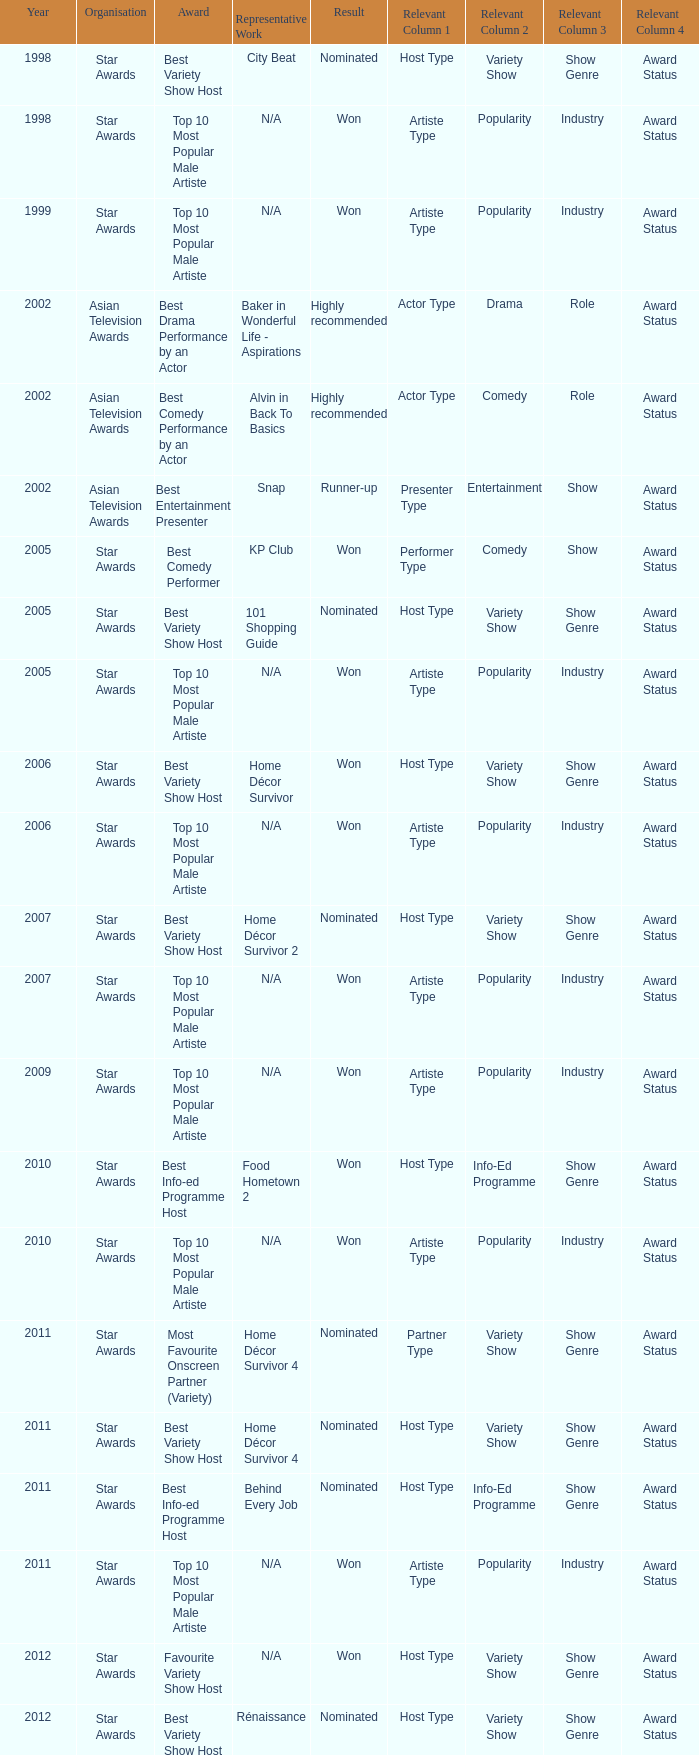What is the name of the Representative Work in a year later than 2005 with a Result of nominated, and an Award of best variety show host? Home Décor Survivor 2, Home Décor Survivor 4, Rénaissance, Jobs Around The World. 